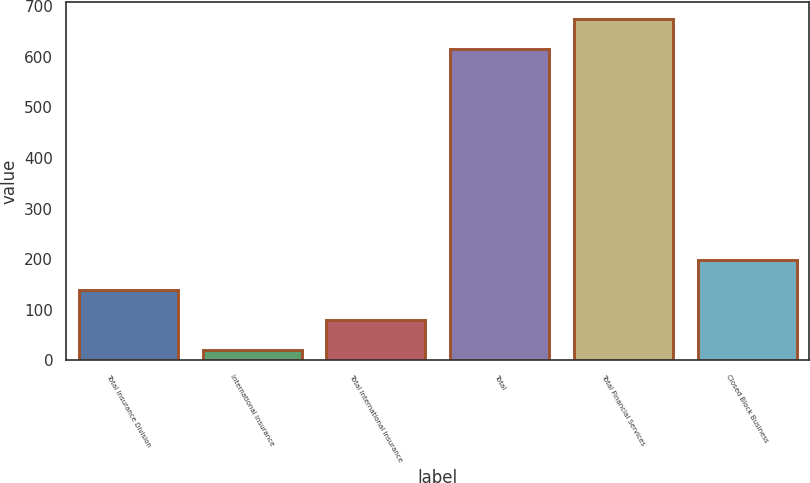Convert chart. <chart><loc_0><loc_0><loc_500><loc_500><bar_chart><fcel>Total Insurance Division<fcel>International Insurance<fcel>Total International Insurance<fcel>Total<fcel>Total Financial Services<fcel>Closed Block Business<nl><fcel>139.2<fcel>20<fcel>79.6<fcel>615<fcel>674.6<fcel>198.8<nl></chart> 